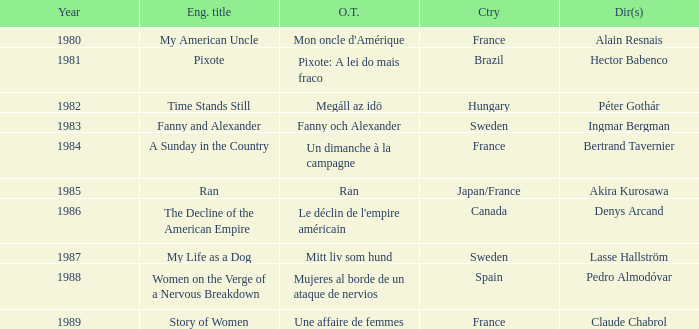What's the English Title of Fanny Och Alexander? Fanny and Alexander. 